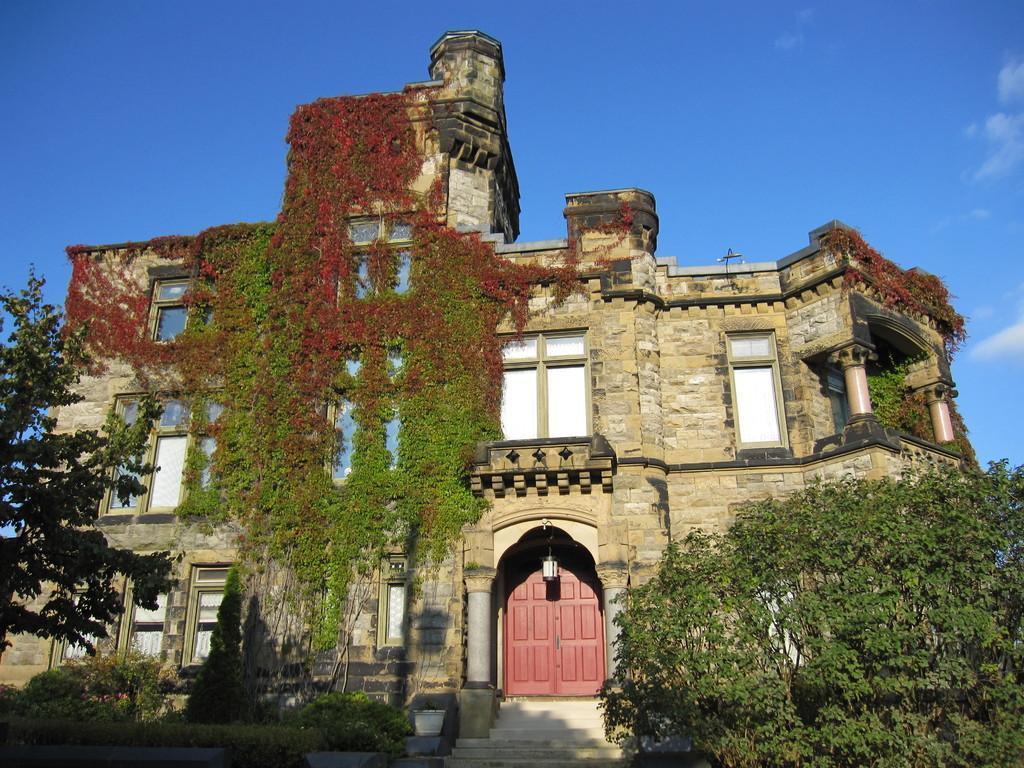Please provide a concise description of this image. In this picture we can see a building with windows and a door. In front of the building there are trees, plants and steps. Behind the building there is the sky. 